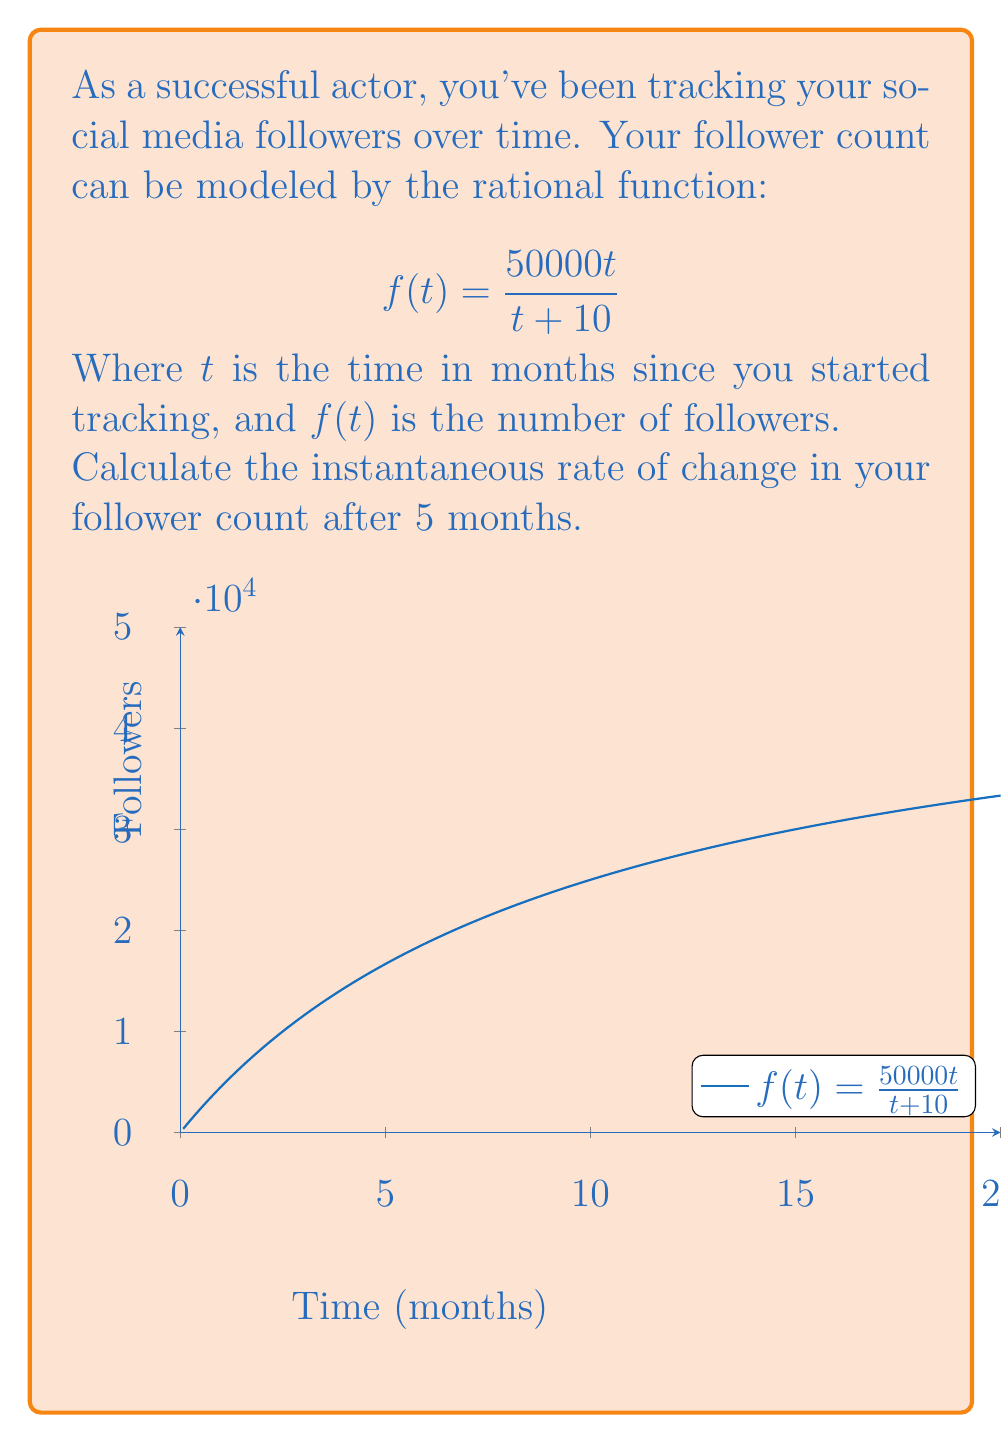Can you answer this question? To find the instantaneous rate of change, we need to calculate the derivative of the function $f(t)$ and then evaluate it at $t = 5$. Let's break this down step-by-step:

1) First, let's find the derivative of $f(t) = \frac{50000t}{t + 10}$ using the quotient rule:

   $$f'(t) = \frac{(t+10)(50000) - 50000t(1)}{(t+10)^2}$$

2) Simplify the numerator:
   
   $$f'(t) = \frac{50000t + 500000 - 50000t}{(t+10)^2} = \frac{500000}{(t+10)^2}$$

3) Now we have the general form of the derivative. To find the instantaneous rate of change at $t = 5$, we substitute $t = 5$ into this expression:

   $$f'(5) = \frac{500000}{(5+10)^2} = \frac{500000}{15^2} = \frac{500000}{225}$$

4) Simplify:
   
   $$f'(5) = \frac{10000}{4.5} \approx 2222.22$$

Therefore, after 5 months, your follower count is increasing at a rate of approximately 2222.22 followers per month.
Answer: $2222.22$ followers/month 